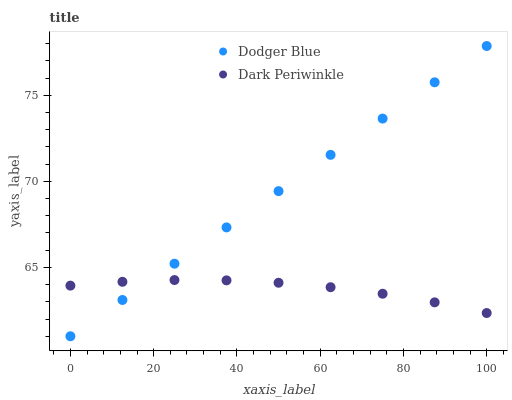Does Dark Periwinkle have the minimum area under the curve?
Answer yes or no. Yes. Does Dodger Blue have the maximum area under the curve?
Answer yes or no. Yes. Does Dark Periwinkle have the maximum area under the curve?
Answer yes or no. No. Is Dodger Blue the smoothest?
Answer yes or no. Yes. Is Dark Periwinkle the roughest?
Answer yes or no. Yes. Is Dark Periwinkle the smoothest?
Answer yes or no. No. Does Dodger Blue have the lowest value?
Answer yes or no. Yes. Does Dark Periwinkle have the lowest value?
Answer yes or no. No. Does Dodger Blue have the highest value?
Answer yes or no. Yes. Does Dark Periwinkle have the highest value?
Answer yes or no. No. Does Dark Periwinkle intersect Dodger Blue?
Answer yes or no. Yes. Is Dark Periwinkle less than Dodger Blue?
Answer yes or no. No. Is Dark Periwinkle greater than Dodger Blue?
Answer yes or no. No. 